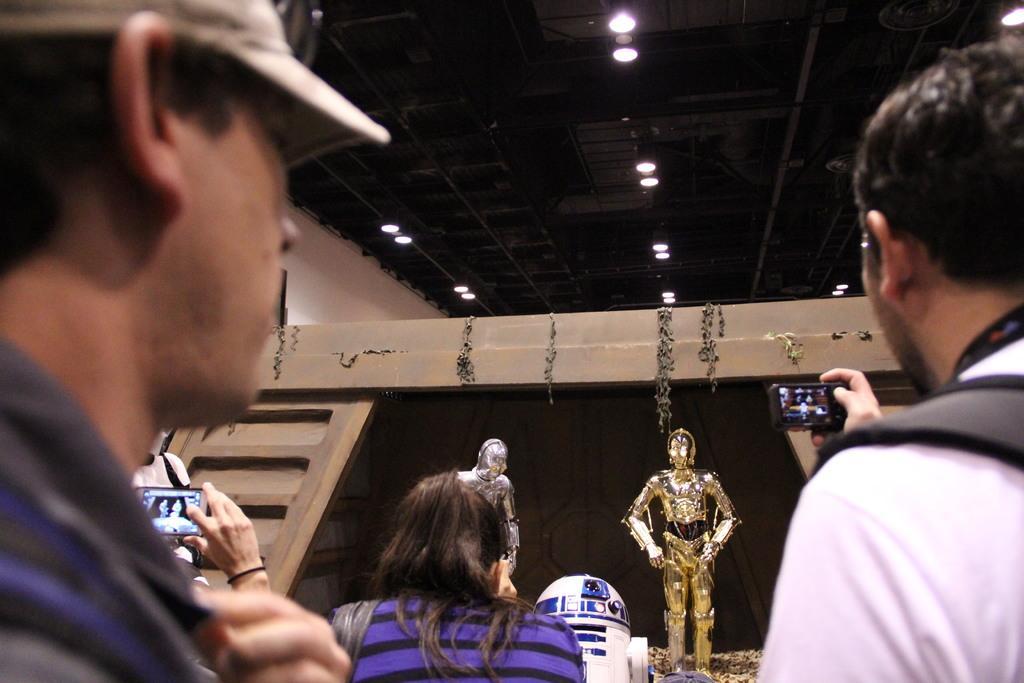How would you summarize this image in a sentence or two? In this image we can see a person capturing the photograph of robots. We can also see a few persons on the left. At the top we can see the ceiling lights to the roof. 